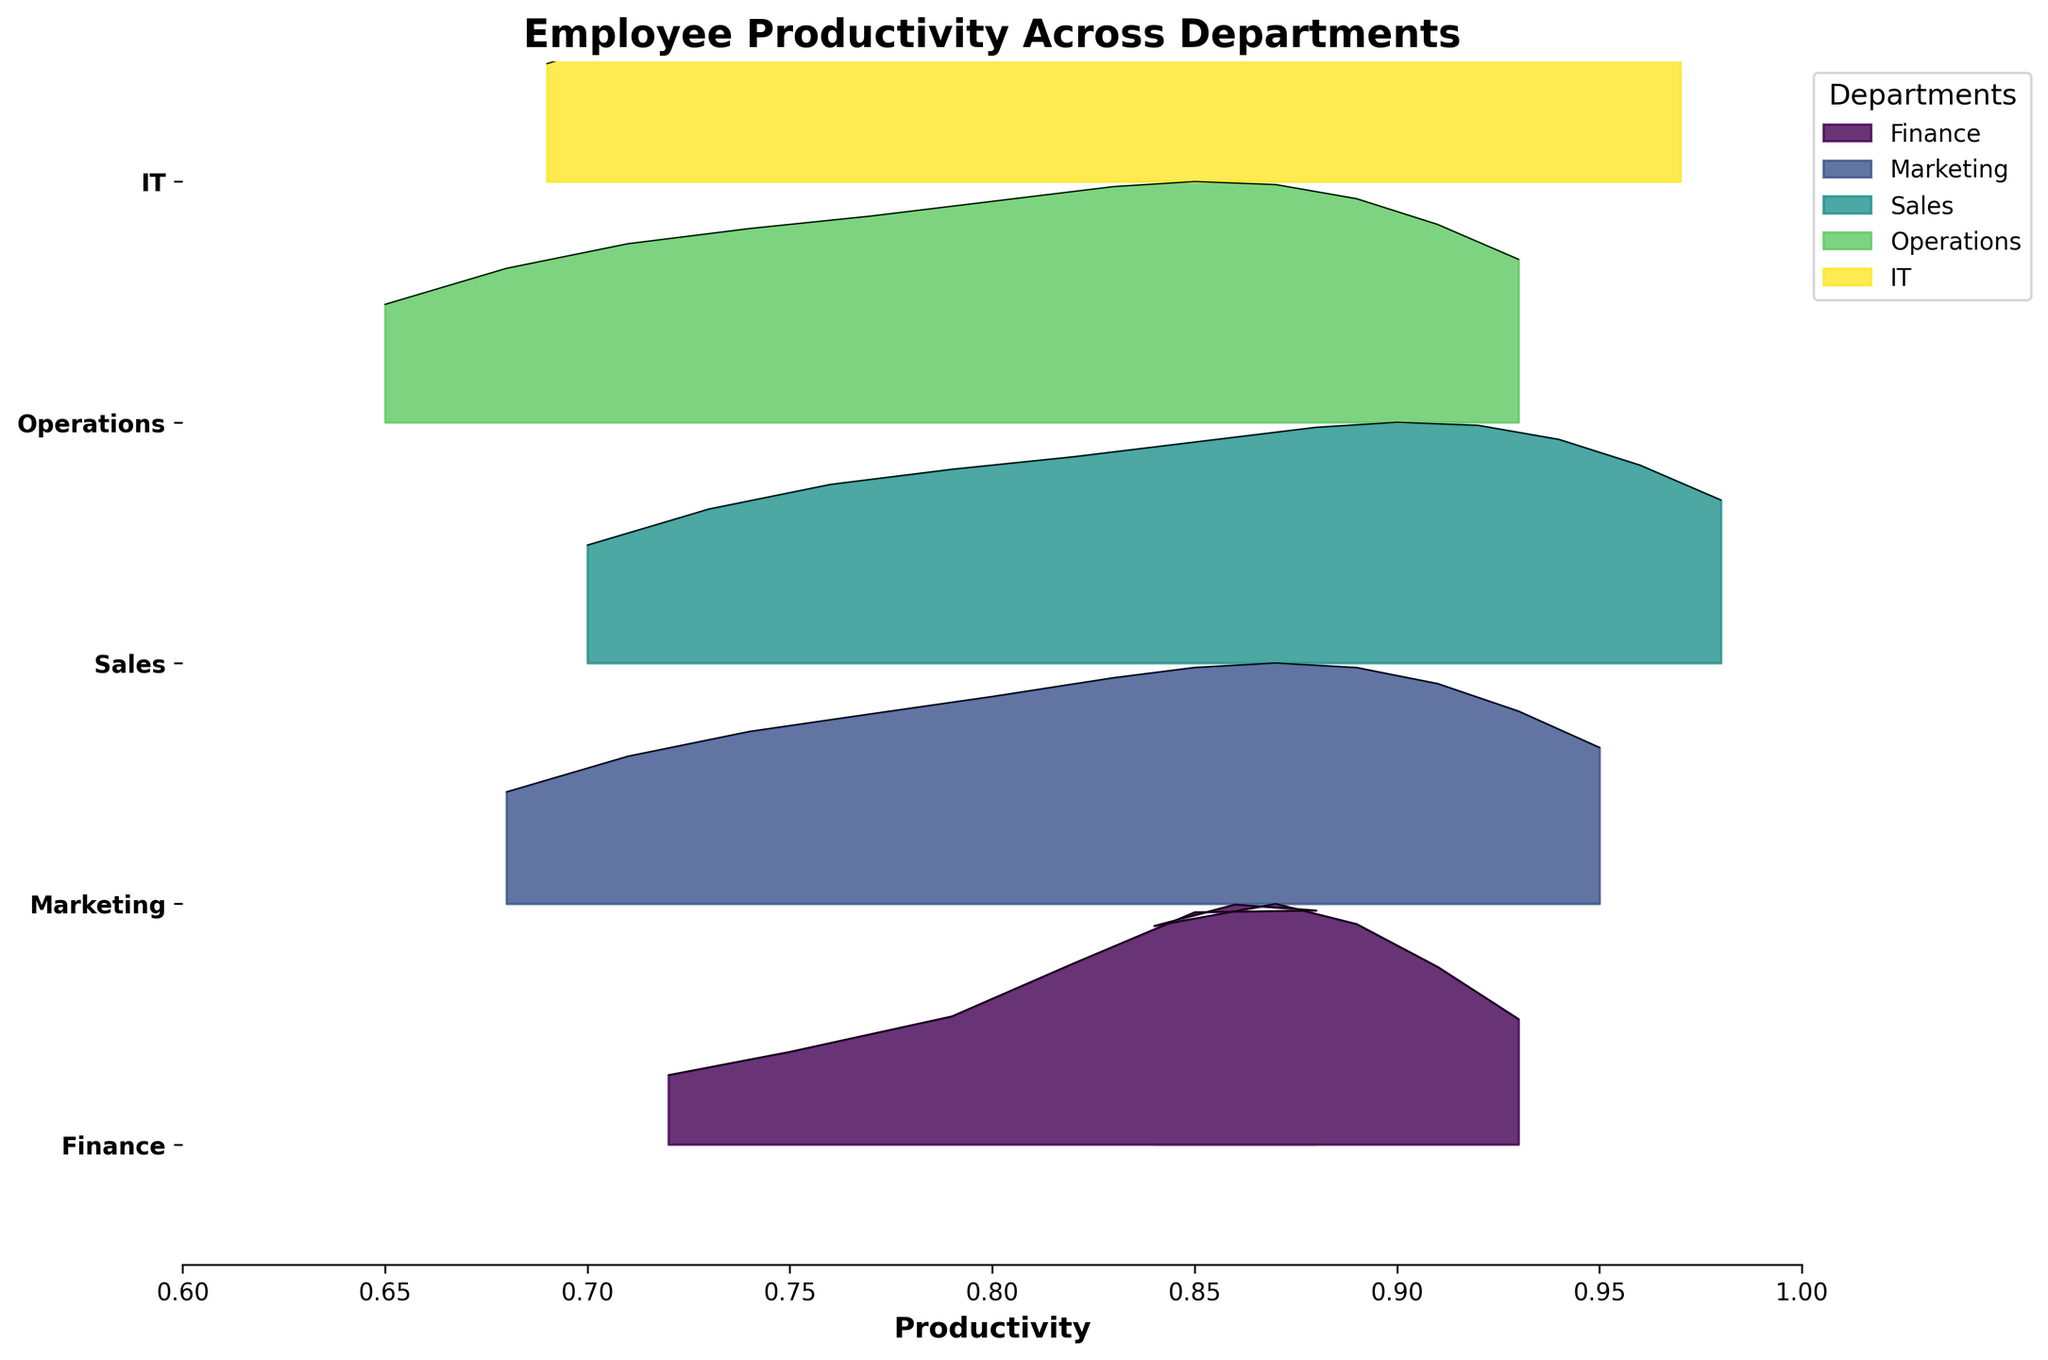What is the title of the plot? The title of a plot is typically found at the top and provides an overview of what the plot represents. In this case, the title "Employee Productivity Across Departments" is displayed at the top of the plot.
Answer: Employee Productivity Across Departments How many departments are shown in the plot? Count the number of unique department labels on the y-axis. Here, they are Finance, Marketing, Sales, Operations, and IT.
Answer: 5 Which department shows the highest productivity level in December? On the x-axis, find the values corresponding to December, then look at the ridges' highest points for each department. IT has the highest value of 0.97.
Answer: IT How does the productivity trend of the Finance department change over the year? Trace the ridgeline for the Finance department from January to December. The line consistently rises, indicating an increasing productivity trend throughout the fiscal year.
Answer: Increasing Which department has the least variance in productivity levels? The department with the smallest spread or tightest clustering of the ridgeline has the least variance. Here, the Finance department's ridgeline appears the tightest.
Answer: Finance Compare the maximum productivity levels of the Sales and IT departments. Which is higher? Locate the maximum points on the ridgelines for Sales and IT departments. Sales reaches a maximum of 0.98, while IT reaches a maximum of 0.97.
Answer: Sales In which month does Marketing show the highest productivity level? Look at the ridgeline for the Marketing department and identify the highest point along the x-axis. This occurs in December at 0.95.
Answer: December What is the primary trend observable across all departments throughout the fiscal year? By following the ridge lines for each department from January to December on the x-axis, it is clear that all department ridgelines are increasing. This indicates a general upward trend in productivity across all departments.
Answer: Upward Trend Which department exhibits an increase in productivity in almost perfect linear steps each month? Check the ridgelines for a department where the productivity levels increase uniformly from month to month. The Sales department displays a nearly linear increase.
Answer: Sales 